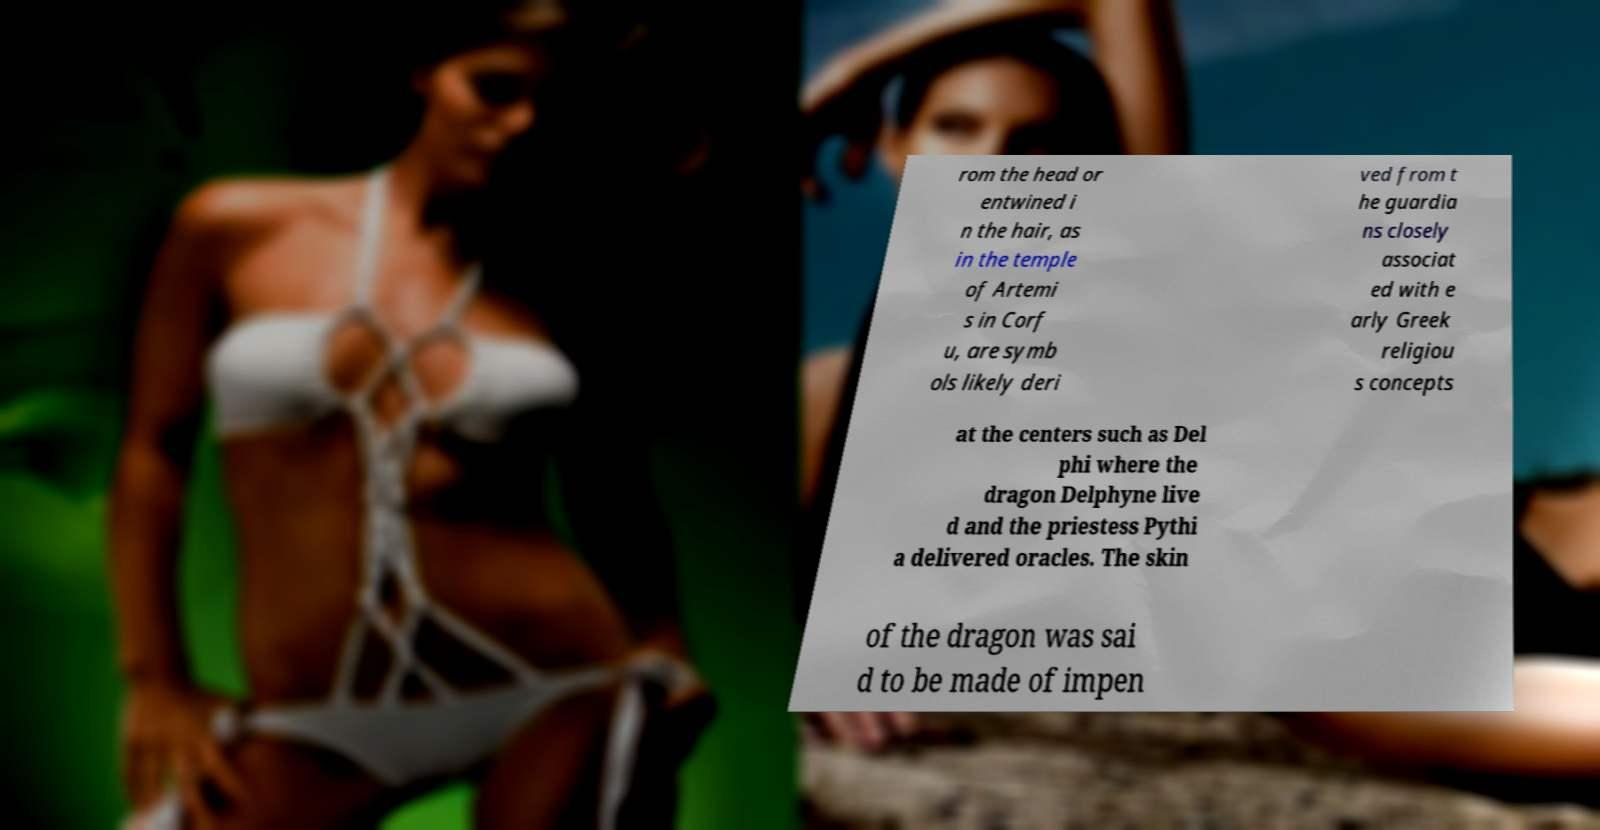Can you read and provide the text displayed in the image?This photo seems to have some interesting text. Can you extract and type it out for me? rom the head or entwined i n the hair, as in the temple of Artemi s in Corf u, are symb ols likely deri ved from t he guardia ns closely associat ed with e arly Greek religiou s concepts at the centers such as Del phi where the dragon Delphyne live d and the priestess Pythi a delivered oracles. The skin of the dragon was sai d to be made of impen 